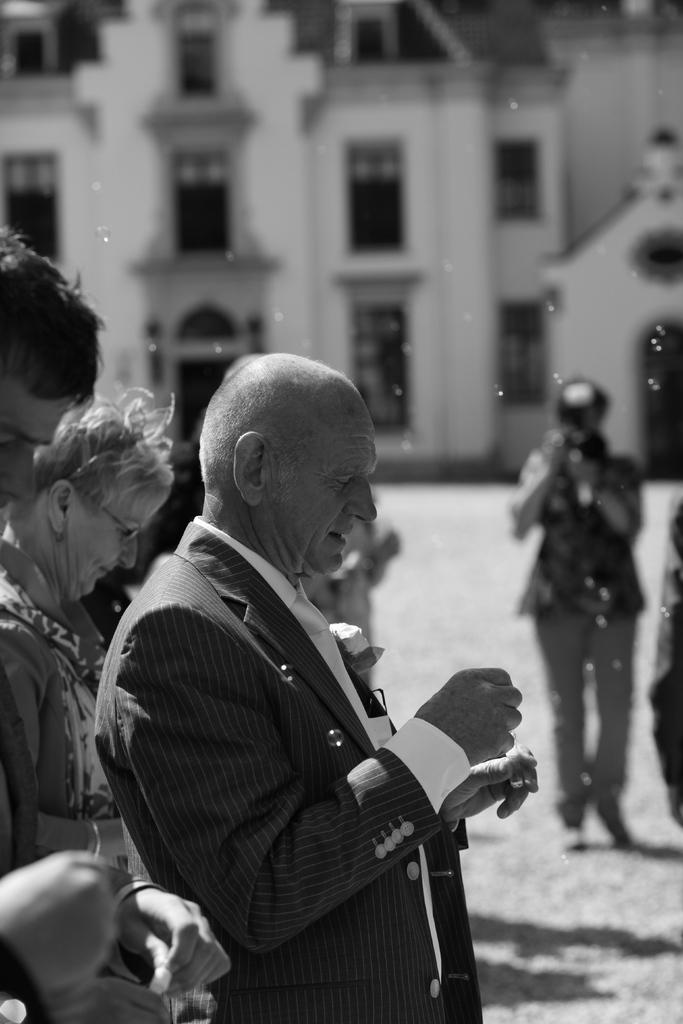What is the color scheme of the image? The image is black and white. What can be seen in the image? There are people standing in the image, and they are holding objects. Can you describe the person holding a camera in the image? Yes, there is a person holding a camera in the image. What is visible in the background of the image? There is a building in the background of the image, and there are windows visible. What type of education is being provided in the image? There is no indication of education being provided in the image; it primarily features people standing and holding objects. Is there any payment being exchanged in the image? There is no indication of payment being exchanged in the image. 